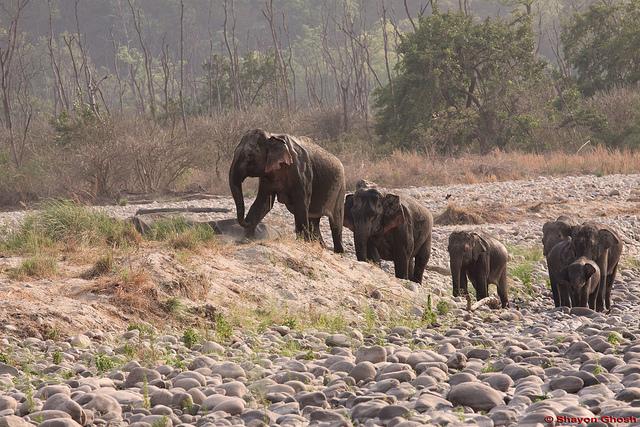How many trees?
Answer briefly. 20. How many adult elephants are in the herd?
Quick response, please. 3. Is that a sunset?
Be succinct. No. Is this in nature?
Keep it brief. Yes. 